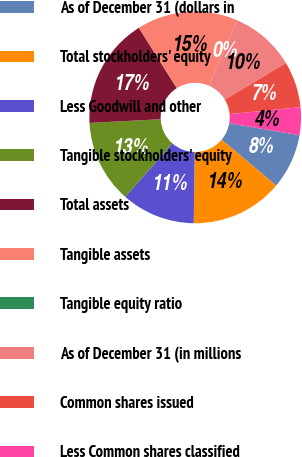Convert chart to OTSL. <chart><loc_0><loc_0><loc_500><loc_500><pie_chart><fcel>As of December 31 (dollars in<fcel>Total stockholders' equity<fcel>Less Goodwill and other<fcel>Tangible stockholders' equity<fcel>Total assets<fcel>Tangible assets<fcel>Tangible equity ratio<fcel>As of December 31 (in millions<fcel>Common shares issued<fcel>Less Common shares classified<nl><fcel>8.45%<fcel>14.08%<fcel>11.27%<fcel>12.68%<fcel>16.9%<fcel>15.49%<fcel>0.0%<fcel>9.86%<fcel>7.04%<fcel>4.23%<nl></chart> 